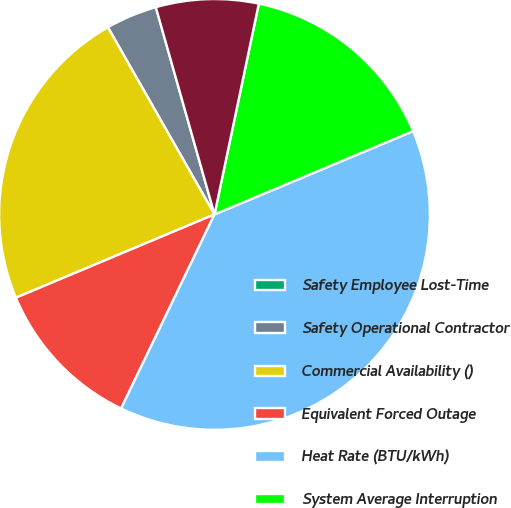<chart> <loc_0><loc_0><loc_500><loc_500><pie_chart><fcel>Safety Employee Lost-Time<fcel>Safety Operational Contractor<fcel>Commercial Availability ()<fcel>Equivalent Forced Outage<fcel>Heat Rate (BTU/kWh)<fcel>System Average Interruption<fcel>Non-Technical Losses ()<nl><fcel>0.0%<fcel>3.85%<fcel>23.08%<fcel>11.54%<fcel>38.46%<fcel>15.38%<fcel>7.69%<nl></chart> 